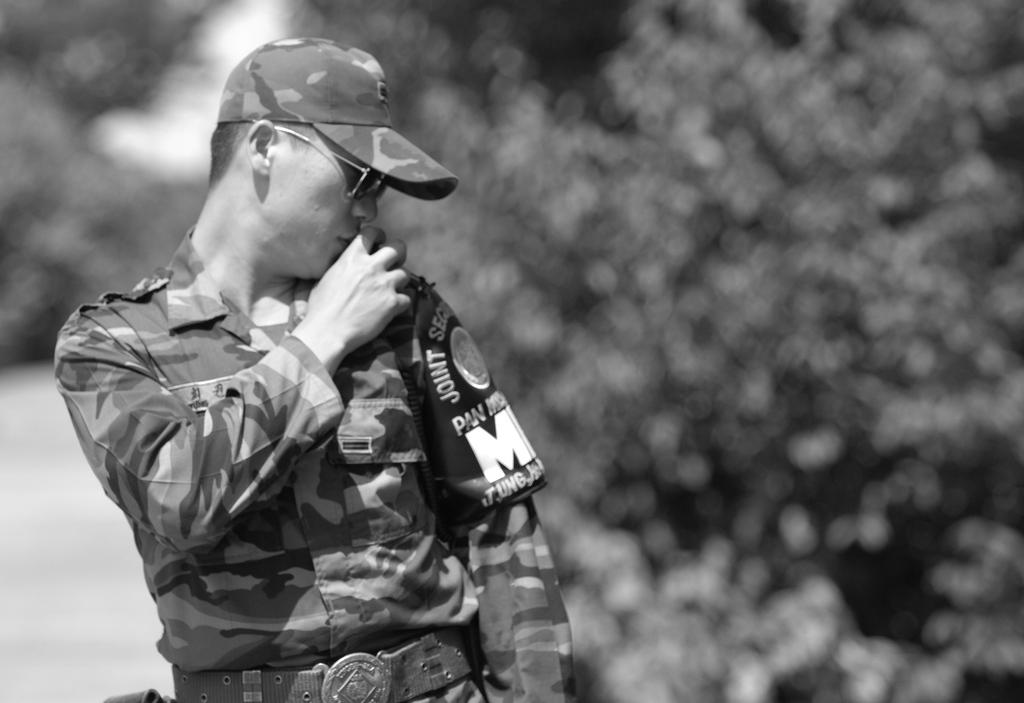What can be seen in the image? There is a person in the image. What is the person wearing on their head? The person is wearing a cap. What accessory is the person wearing on their face? The person is wearing glasses. How would you describe the background of the image? The background of the image is blurred. What type of lip balm is the person applying in the image? There is no lip balm or any indication of the person applying anything in the image. 